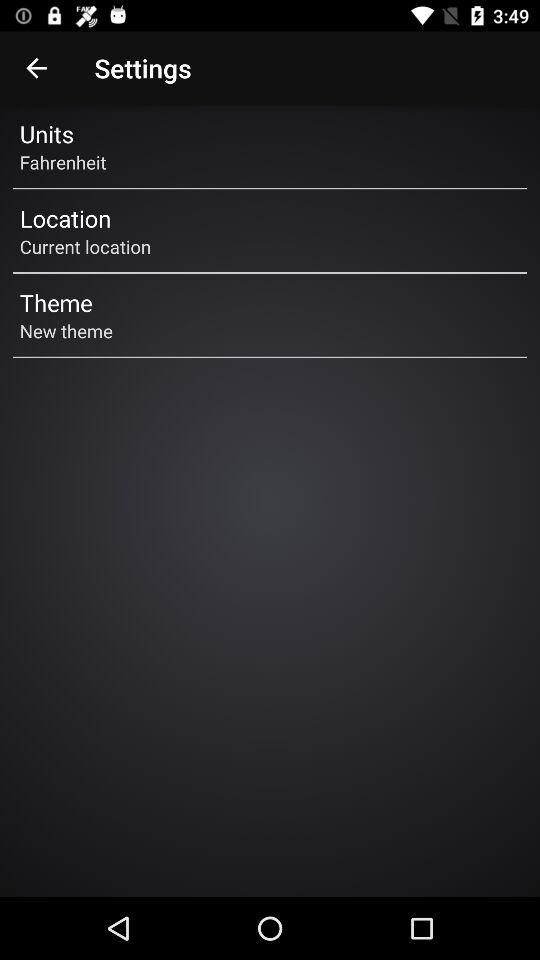How many items are there in the settings menu?
Answer the question using a single word or phrase. 3 